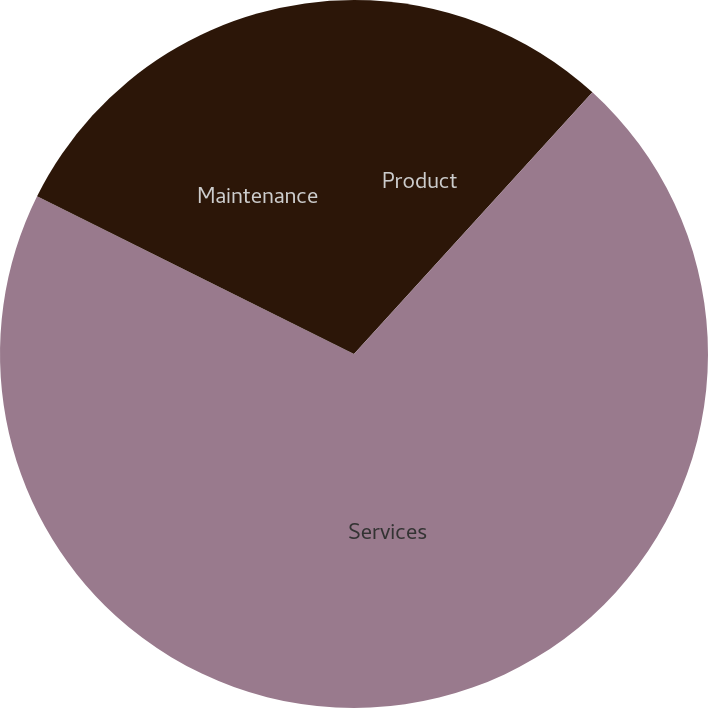<chart> <loc_0><loc_0><loc_500><loc_500><pie_chart><fcel>Product<fcel>Services<fcel>Maintenance<nl><fcel>11.76%<fcel>70.59%<fcel>17.65%<nl></chart> 